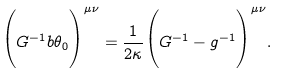<formula> <loc_0><loc_0><loc_500><loc_500>\Big { ( } G ^ { - 1 } b \theta _ { 0 } \Big { ) } ^ { \mu \nu } = \frac { 1 } { 2 \kappa } \Big { ( } G ^ { - 1 } - g ^ { - 1 } \Big { ) } ^ { \mu \nu } .</formula> 